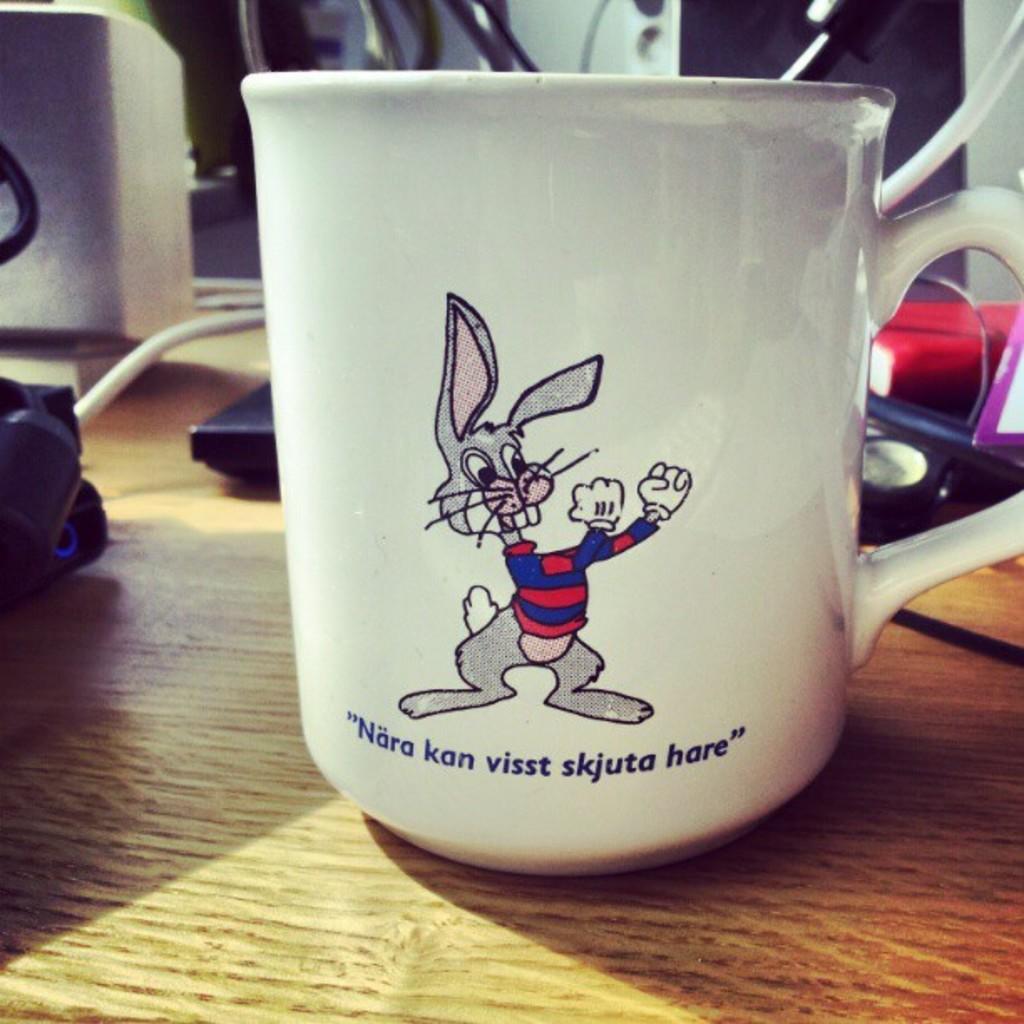What is the quote on the mug?
Ensure brevity in your answer.  Nara kan visst skjuta hare. What color is the quote on the mug?
Keep it short and to the point. Blue. 